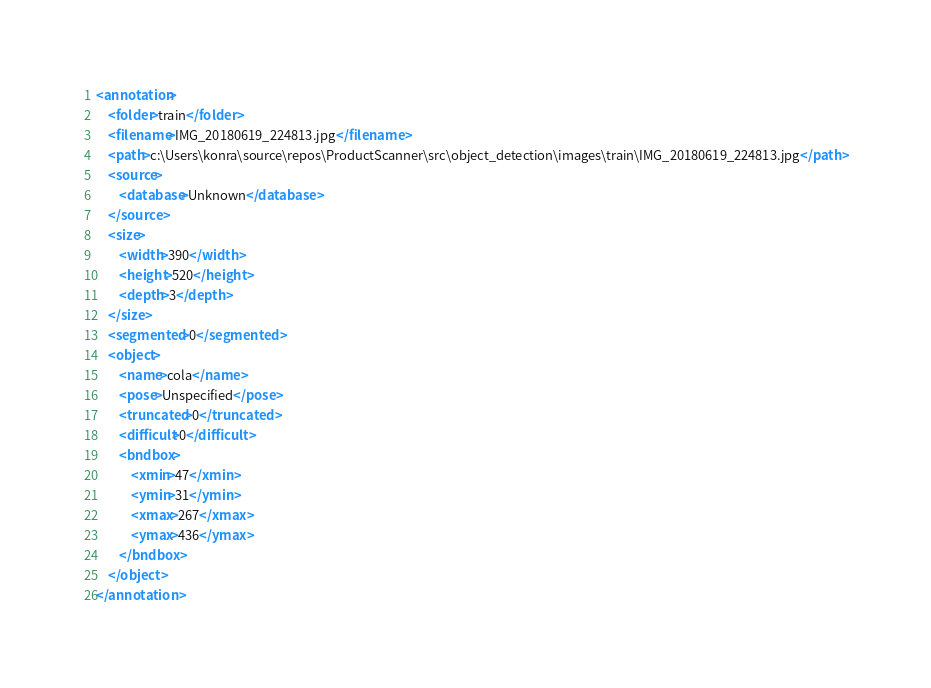<code> <loc_0><loc_0><loc_500><loc_500><_XML_><annotation>
	<folder>train</folder>
	<filename>IMG_20180619_224813.jpg</filename>
	<path>c:\Users\konra\source\repos\ProductScanner\src\object_detection\images\train\IMG_20180619_224813.jpg</path>
	<source>
		<database>Unknown</database>
	</source>
	<size>
		<width>390</width>
		<height>520</height>
		<depth>3</depth>
	</size>
	<segmented>0</segmented>
	<object>
		<name>cola</name>
		<pose>Unspecified</pose>
		<truncated>0</truncated>
		<difficult>0</difficult>
		<bndbox>
			<xmin>47</xmin>
			<ymin>31</ymin>
			<xmax>267</xmax>
			<ymax>436</ymax>
		</bndbox>
	</object>
</annotation>
</code> 